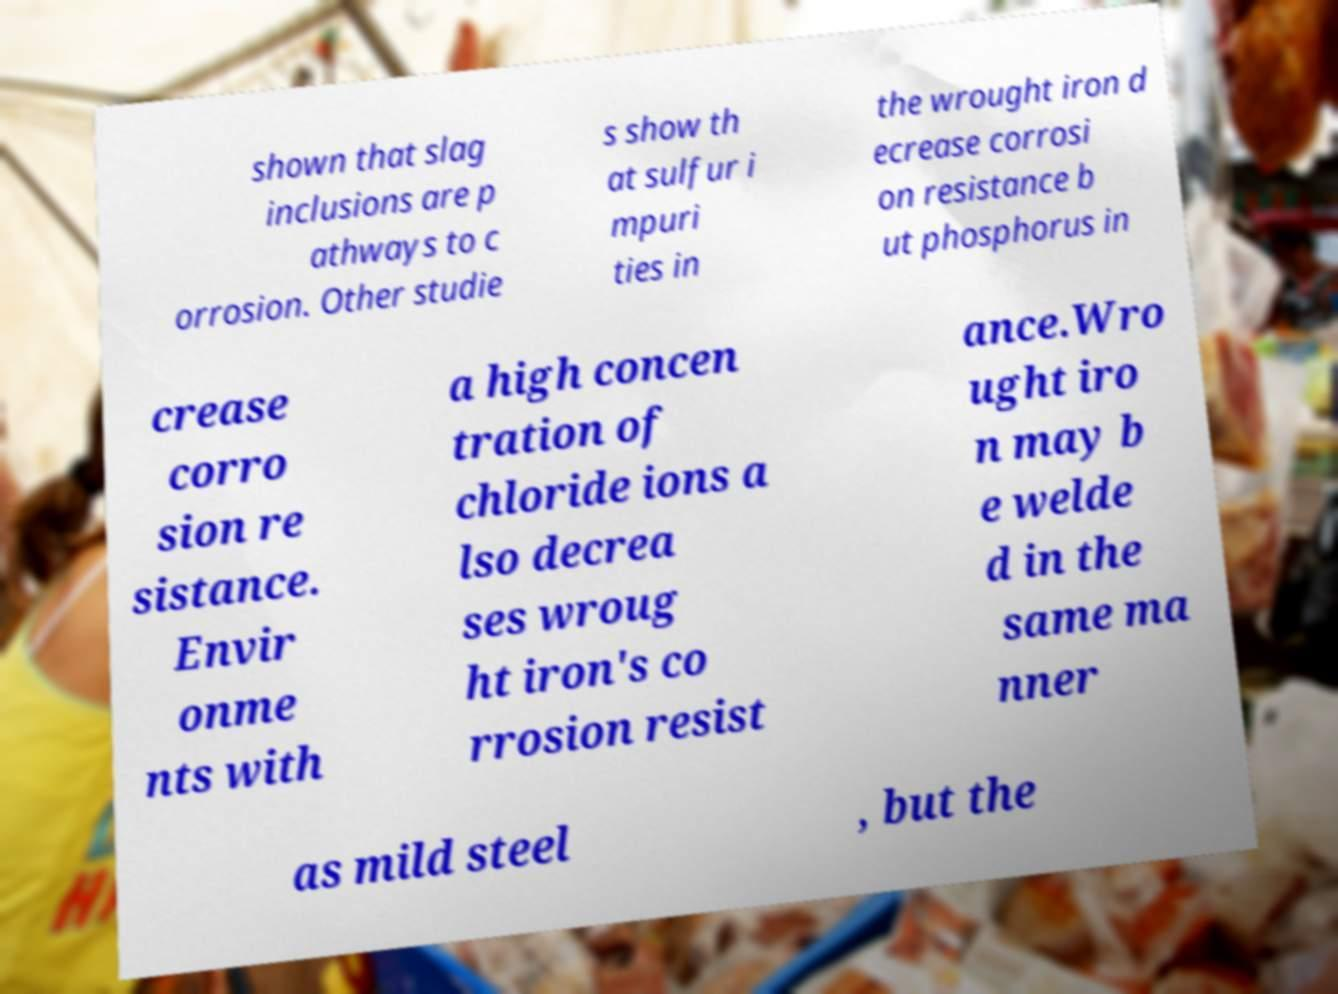Please identify and transcribe the text found in this image. shown that slag inclusions are p athways to c orrosion. Other studie s show th at sulfur i mpuri ties in the wrought iron d ecrease corrosi on resistance b ut phosphorus in crease corro sion re sistance. Envir onme nts with a high concen tration of chloride ions a lso decrea ses wroug ht iron's co rrosion resist ance.Wro ught iro n may b e welde d in the same ma nner as mild steel , but the 